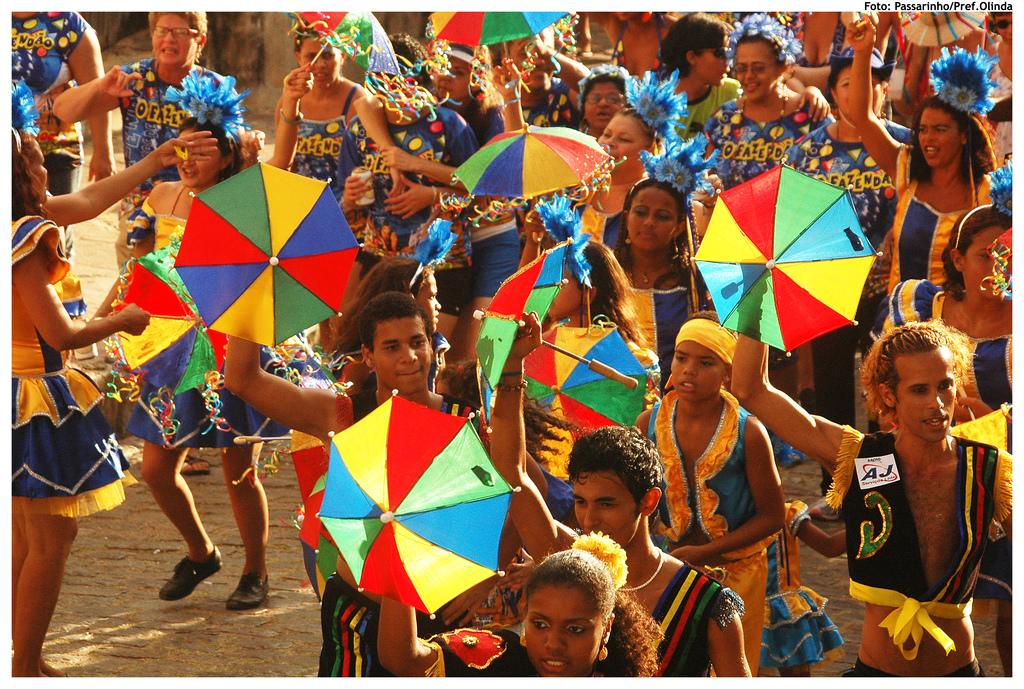What two letters are on the mans shirt?
Ensure brevity in your answer.  Aj. 